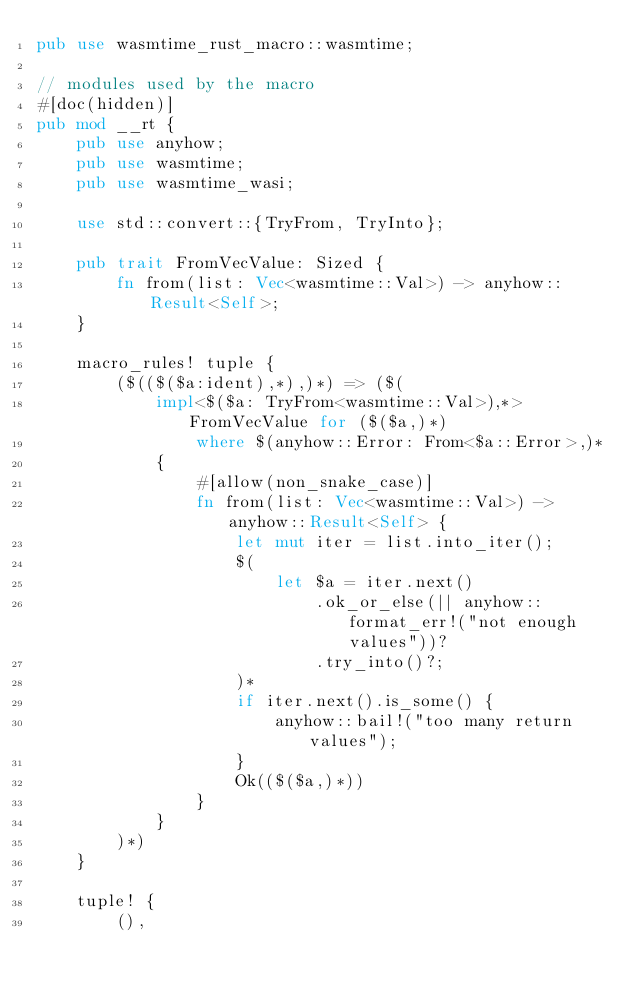Convert code to text. <code><loc_0><loc_0><loc_500><loc_500><_Rust_>pub use wasmtime_rust_macro::wasmtime;

// modules used by the macro
#[doc(hidden)]
pub mod __rt {
    pub use anyhow;
    pub use wasmtime;
    pub use wasmtime_wasi;

    use std::convert::{TryFrom, TryInto};

    pub trait FromVecValue: Sized {
        fn from(list: Vec<wasmtime::Val>) -> anyhow::Result<Self>;
    }

    macro_rules! tuple {
        ($(($($a:ident),*),)*) => ($(
            impl<$($a: TryFrom<wasmtime::Val>),*> FromVecValue for ($($a,)*)
                where $(anyhow::Error: From<$a::Error>,)*
            {
                #[allow(non_snake_case)]
                fn from(list: Vec<wasmtime::Val>) -> anyhow::Result<Self> {
                    let mut iter = list.into_iter();
                    $(
                        let $a = iter.next()
                            .ok_or_else(|| anyhow::format_err!("not enough values"))?
                            .try_into()?;
                    )*
                    if iter.next().is_some() {
                        anyhow::bail!("too many return values");
                    }
                    Ok(($($a,)*))
                }
            }
        )*)
    }

    tuple! {
        (),</code> 